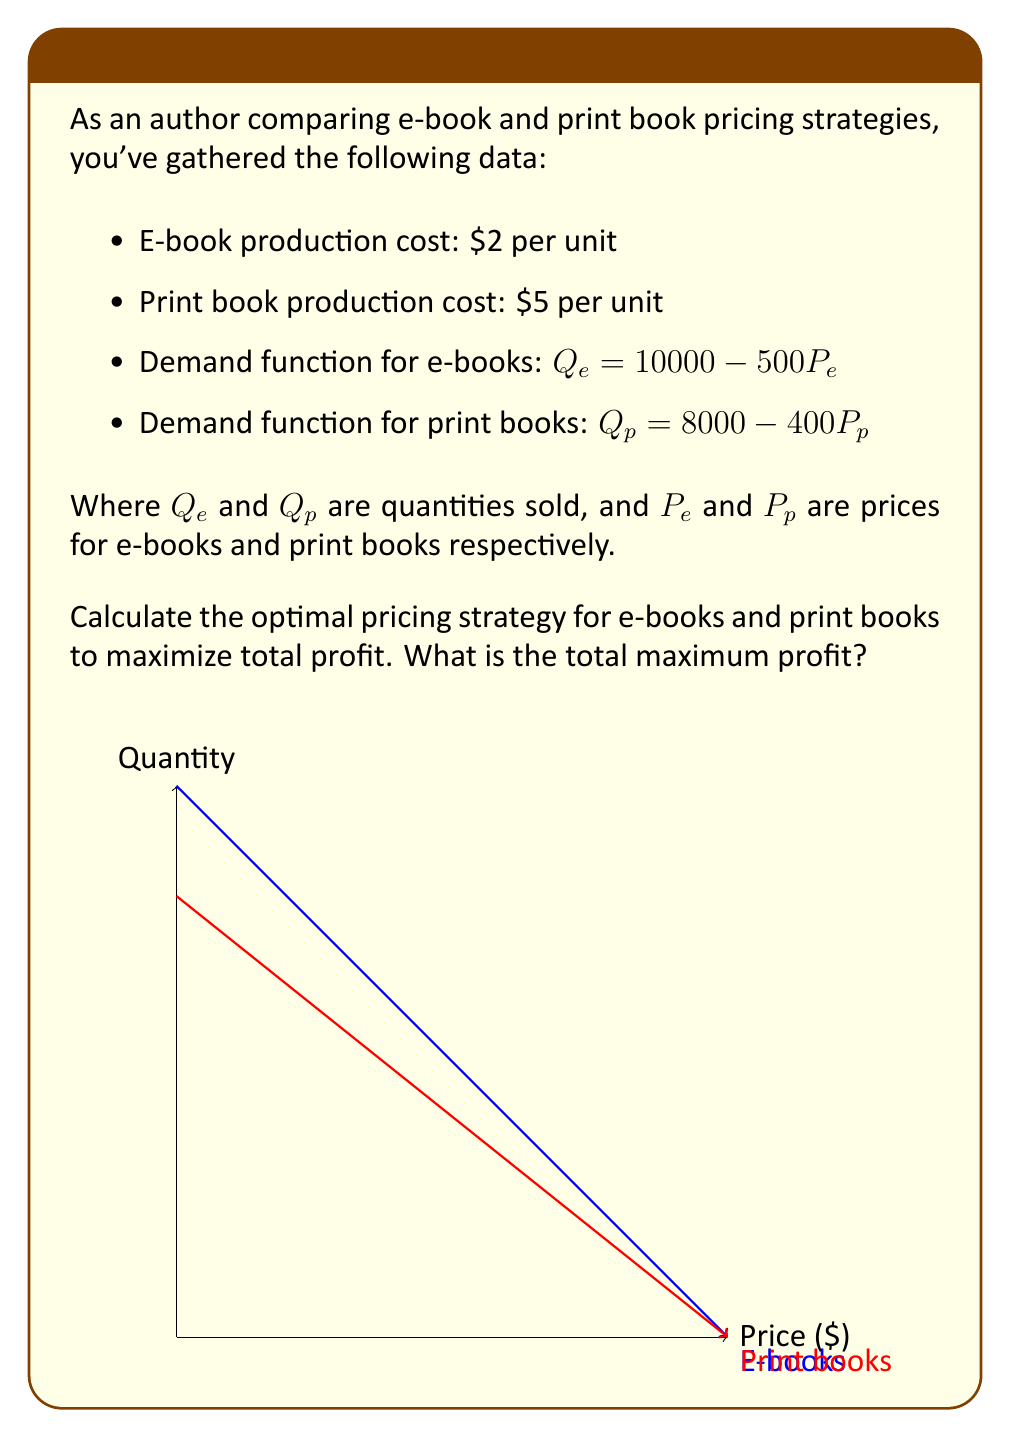Could you help me with this problem? Let's approach this step-by-step:

1) First, we need to set up profit functions for both e-books and print books.

   For e-books: $\pi_e = P_e Q_e - 2Q_e = P_e(10000 - 500P_e) - 2(10000 - 500P_e)$
   For print books: $\pi_p = P_p Q_p - 5Q_p = P_p(8000 - 400P_p) - 5(8000 - 400P_p)$

2) To find the optimal prices, we need to differentiate these functions with respect to price and set them to zero:

   For e-books: 
   $$\frac{d\pi_e}{dP_e} = 10000 - 1000P_e + 1000 = 0$$
   $$11000 = 1000P_e$$
   $$P_e = 11$$

   For print books:
   $$\frac{d\pi_p}{dP_p} = 8000 - 800P_p + 2000 = 0$$
   $$10000 = 800P_p$$
   $$P_p = 12.5$$

3) Now we can calculate the quantities sold at these prices:

   For e-books: $Q_e = 10000 - 500(11) = 4500$
   For print books: $Q_p = 8000 - 400(12.5) = 3000$

4) Finally, we can calculate the profits:

   For e-books: $\pi_e = 11 * 4500 - 2 * 4500 = 40500$
   For print books: $\pi_p = 12.5 * 3000 - 5 * 3000 = 22500$

5) The total maximum profit is the sum of these two: $40500 + 22500 = 63000$
Answer: Optimal e-book price: $11, Optimal print book price: $12.50, Total maximum profit: $63,000 